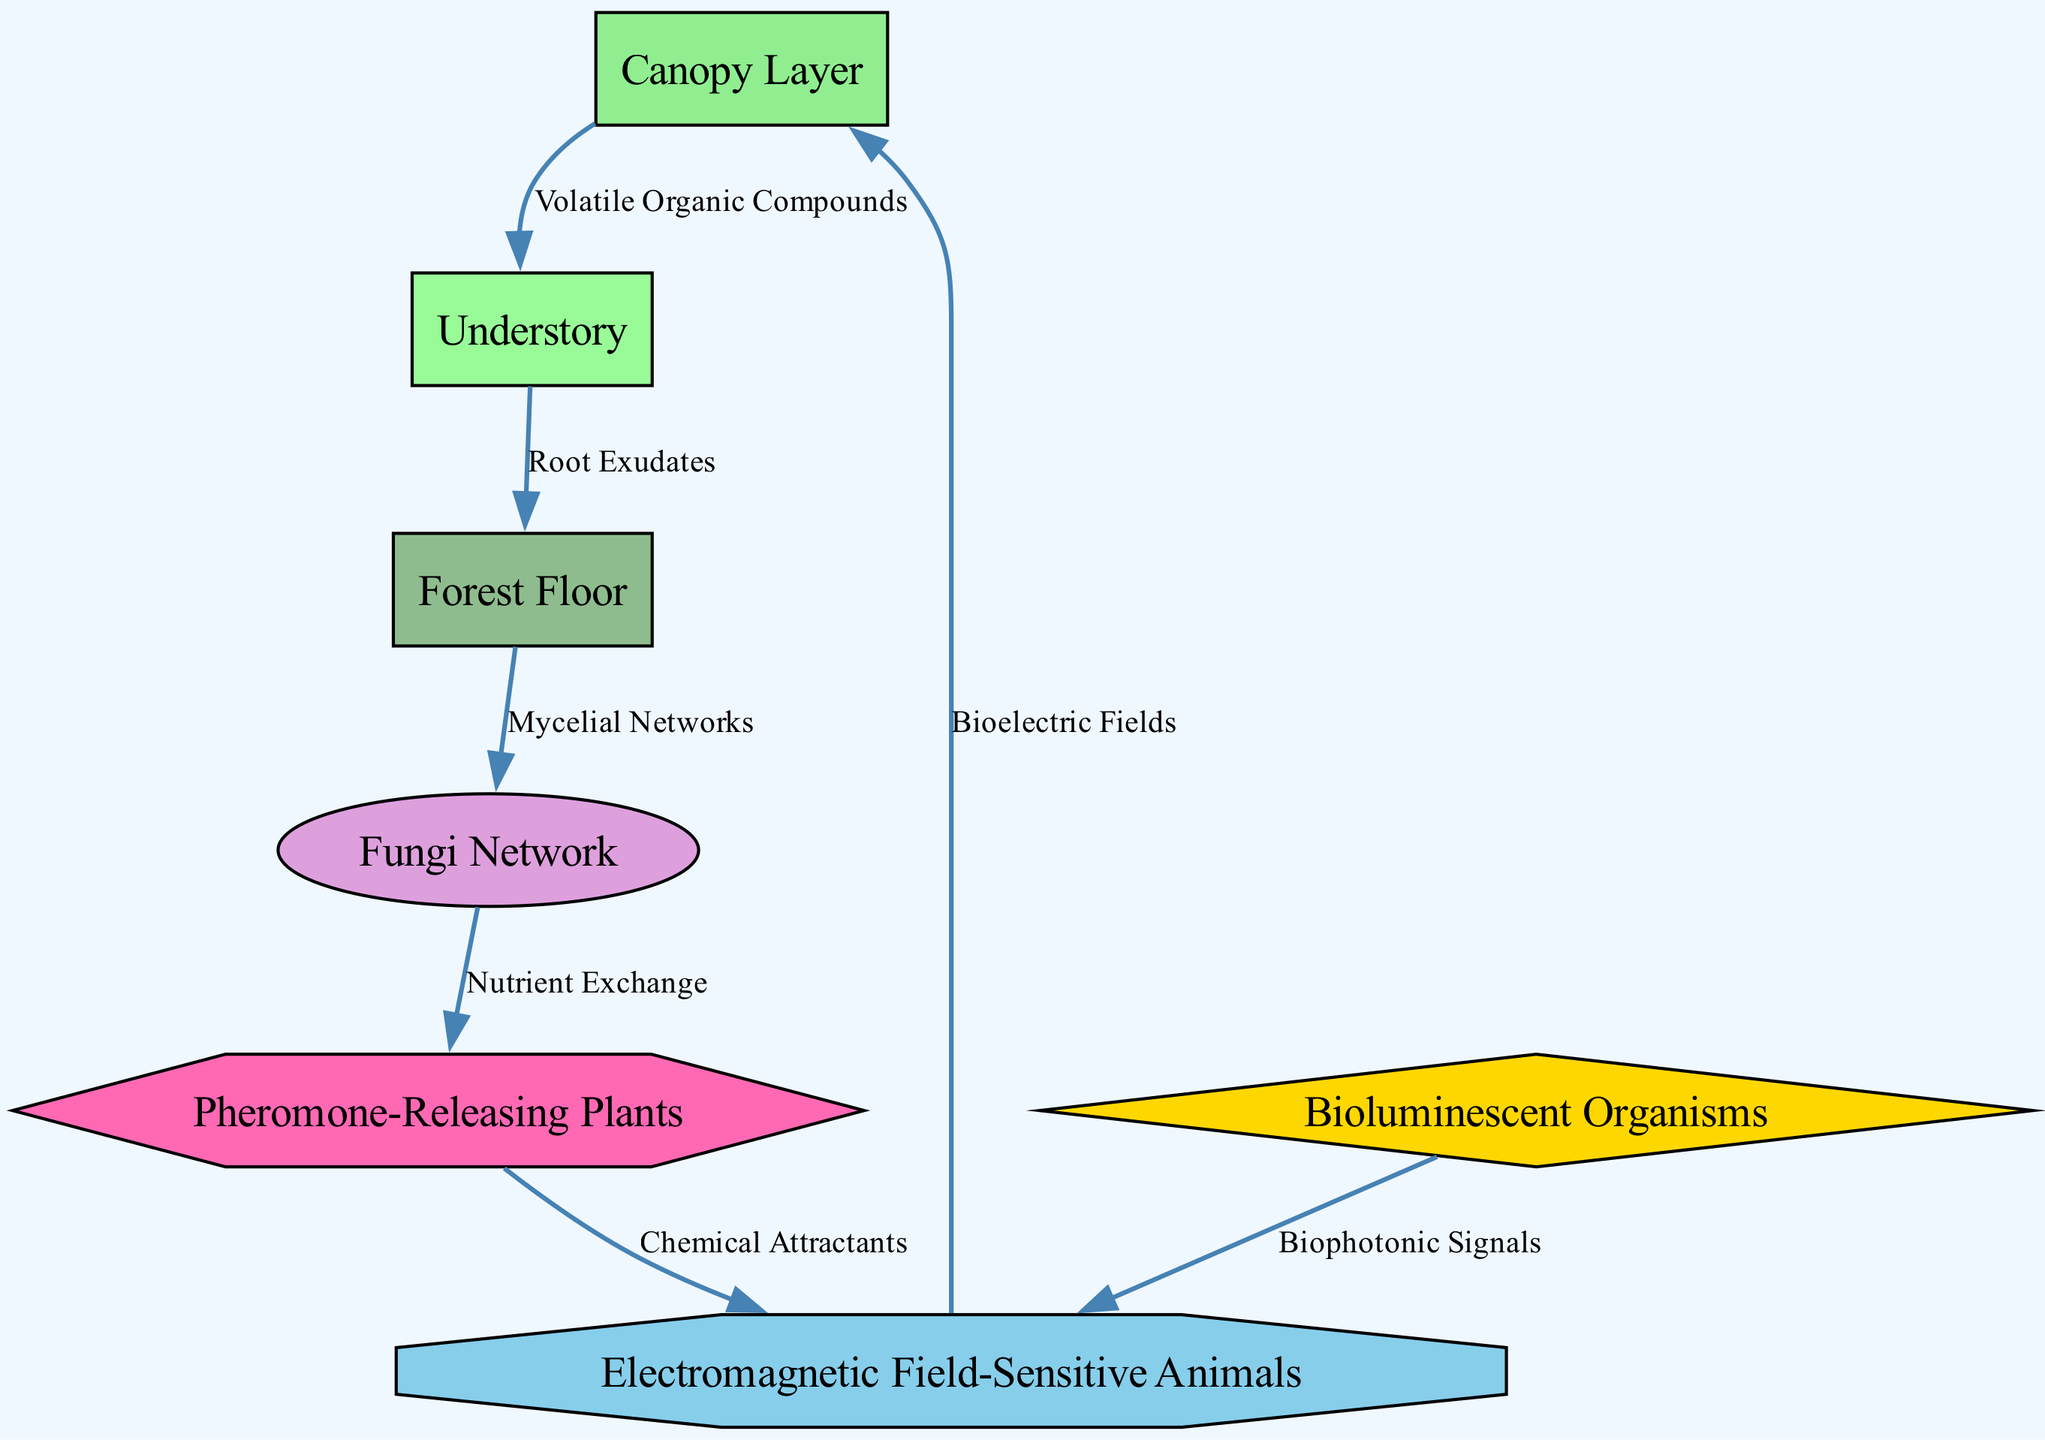How many nodes are present in the diagram? The diagram consists of seven distinct nodes: Canopy Layer, Understory, Forest Floor, Fungi Network, Bioluminescent Organisms, Pheromone-Releasing Plants, and Electromagnetic Field-Sensitive Animals. Thus, counting these nodes gives us a total of seven.
Answer: 7 What type of signal links the Canopy Layer to the Understory? The edge connecting the Canopy Layer (node 1) to the Understory (node 2) is labeled "Volatile Organic Compounds," which indicates that this specific type of signal facilitates interaction between these two layers.
Answer: Volatile Organic Compounds Which node connects to the Fungi Network? The diagram shows that the Forest Floor (node 3) connects to the Fungi Network (node 4) via the edge labeled "Mycelial Networks." Thus, the Forest Floor is the node that connects to the Fungi Network.
Answer: Forest Floor What is the relationship between Pheromone-Releasing Plants and Electromagnetic Field-Sensitive Animals? The edge shows that Pheromone-Releasing Plants (node 6) release "Chemical Attractants" that connect to Electromagnetic Field-Sensitive Animals (node 7). This indicates that Pheromone-Releasing Plants chemically signal or attract these animals.
Answer: Chemical Attractants How do Bioluminescent Organisms communicate with Electromagnetic Field-Sensitive Animals? In the diagram, Bioluminescent Organisms (node 5) send signals through "Biophotonic Signals," which connect directly to Electromagnetic Field-Sensitive Animals (node 7). This suggests a form of light-based communication from the organisms to the animals.
Answer: Biophotonic Signals What signals are involved in the nutrient exchange between the Fungi Network and Pheromone-Releasing Plants? The diagram indicates that the nutrient exchange is represented by an edge between the Fungi Network (node 4) and Pheromone-Releasing Plants (node 6) without a specific label, which infers a general type of exchange, emphasizing the role of Fungi in nutrient cycling.
Answer: Nutrient Exchange Which layer corresponds to the lowest position in the rainforest diagram? The Forest Floor (node 3) is depicted at the bottom level of the diagram, indicating that it is the lowest positional layer within the rainforest ecosystem represented in the diagram.
Answer: Forest Floor 